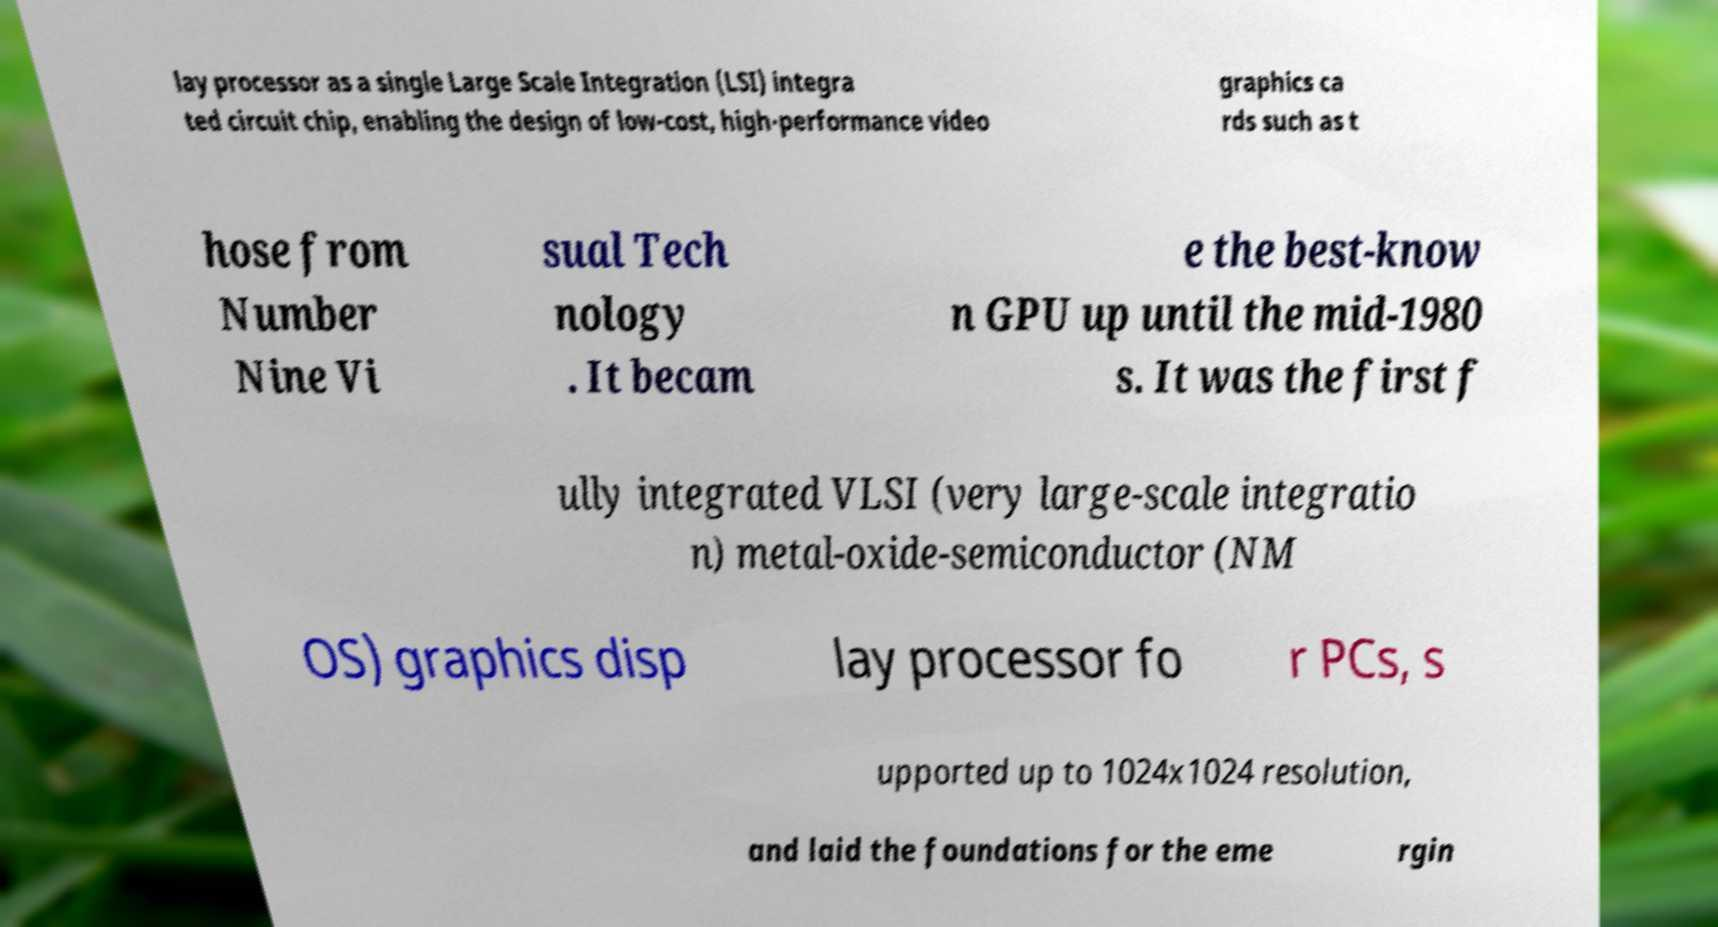Can you read and provide the text displayed in the image?This photo seems to have some interesting text. Can you extract and type it out for me? lay processor as a single Large Scale Integration (LSI) integra ted circuit chip, enabling the design of low-cost, high-performance video graphics ca rds such as t hose from Number Nine Vi sual Tech nology . It becam e the best-know n GPU up until the mid-1980 s. It was the first f ully integrated VLSI (very large-scale integratio n) metal-oxide-semiconductor (NM OS) graphics disp lay processor fo r PCs, s upported up to 1024x1024 resolution, and laid the foundations for the eme rgin 